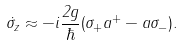<formula> <loc_0><loc_0><loc_500><loc_500>\dot { \sigma } _ { z } \approx - i \frac { 2 g } \hbar { ( } \sigma _ { + } a ^ { + } - a \sigma _ { - } ) .</formula> 